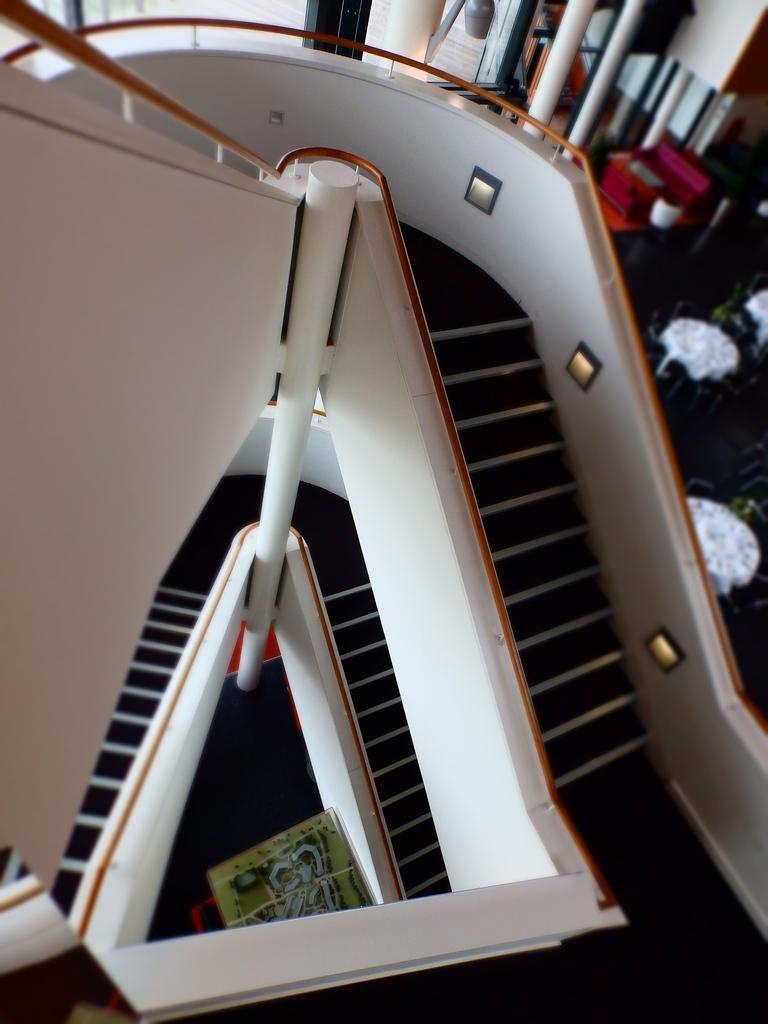Please provide a concise description of this image. In this image, we can see stairs with railing, lights and pole. Here we can see some board. Background there are so many poles, some objects we can see. 